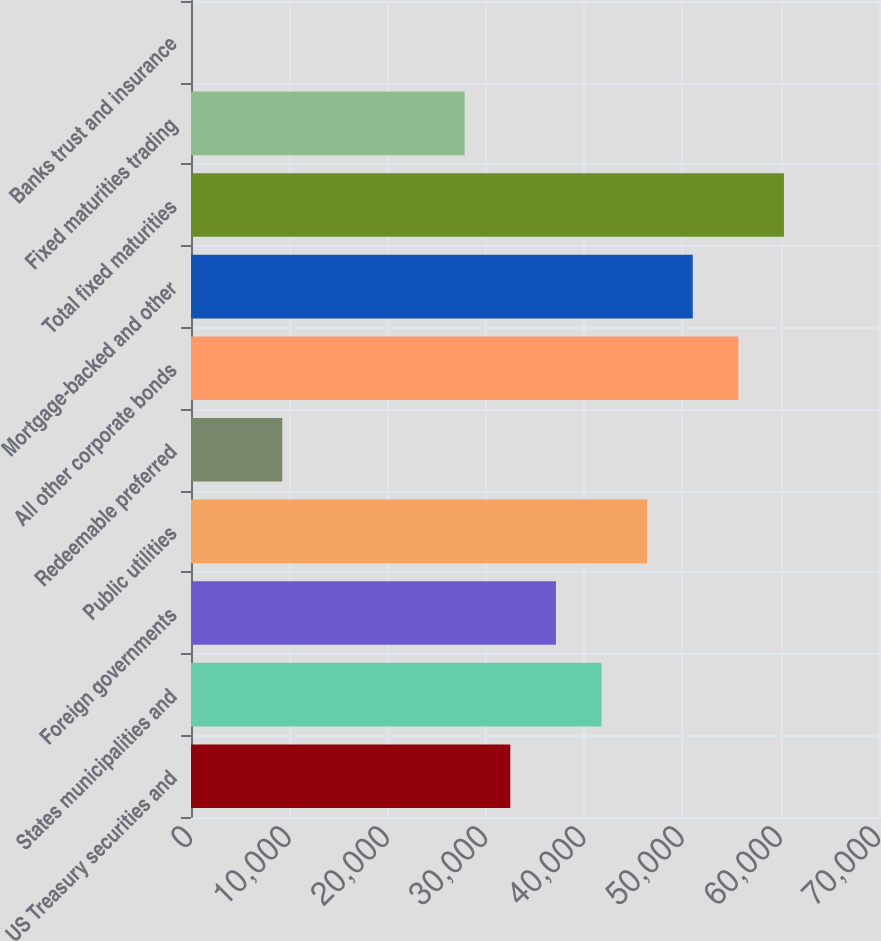<chart> <loc_0><loc_0><loc_500><loc_500><bar_chart><fcel>US Treasury securities and<fcel>States municipalities and<fcel>Foreign governments<fcel>Public utilities<fcel>Redeemable preferred<fcel>All other corporate bonds<fcel>Mortgage-backed and other<fcel>Total fixed maturities<fcel>Fixed maturities trading<fcel>Banks trust and insurance<nl><fcel>32487.5<fcel>41768.3<fcel>37127.9<fcel>46408.7<fcel>9285.42<fcel>55689.5<fcel>51049.1<fcel>60329.9<fcel>27847.1<fcel>4.6<nl></chart> 